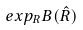Convert formula to latex. <formula><loc_0><loc_0><loc_500><loc_500>e x p _ { R } B ( \hat { R } )</formula> 